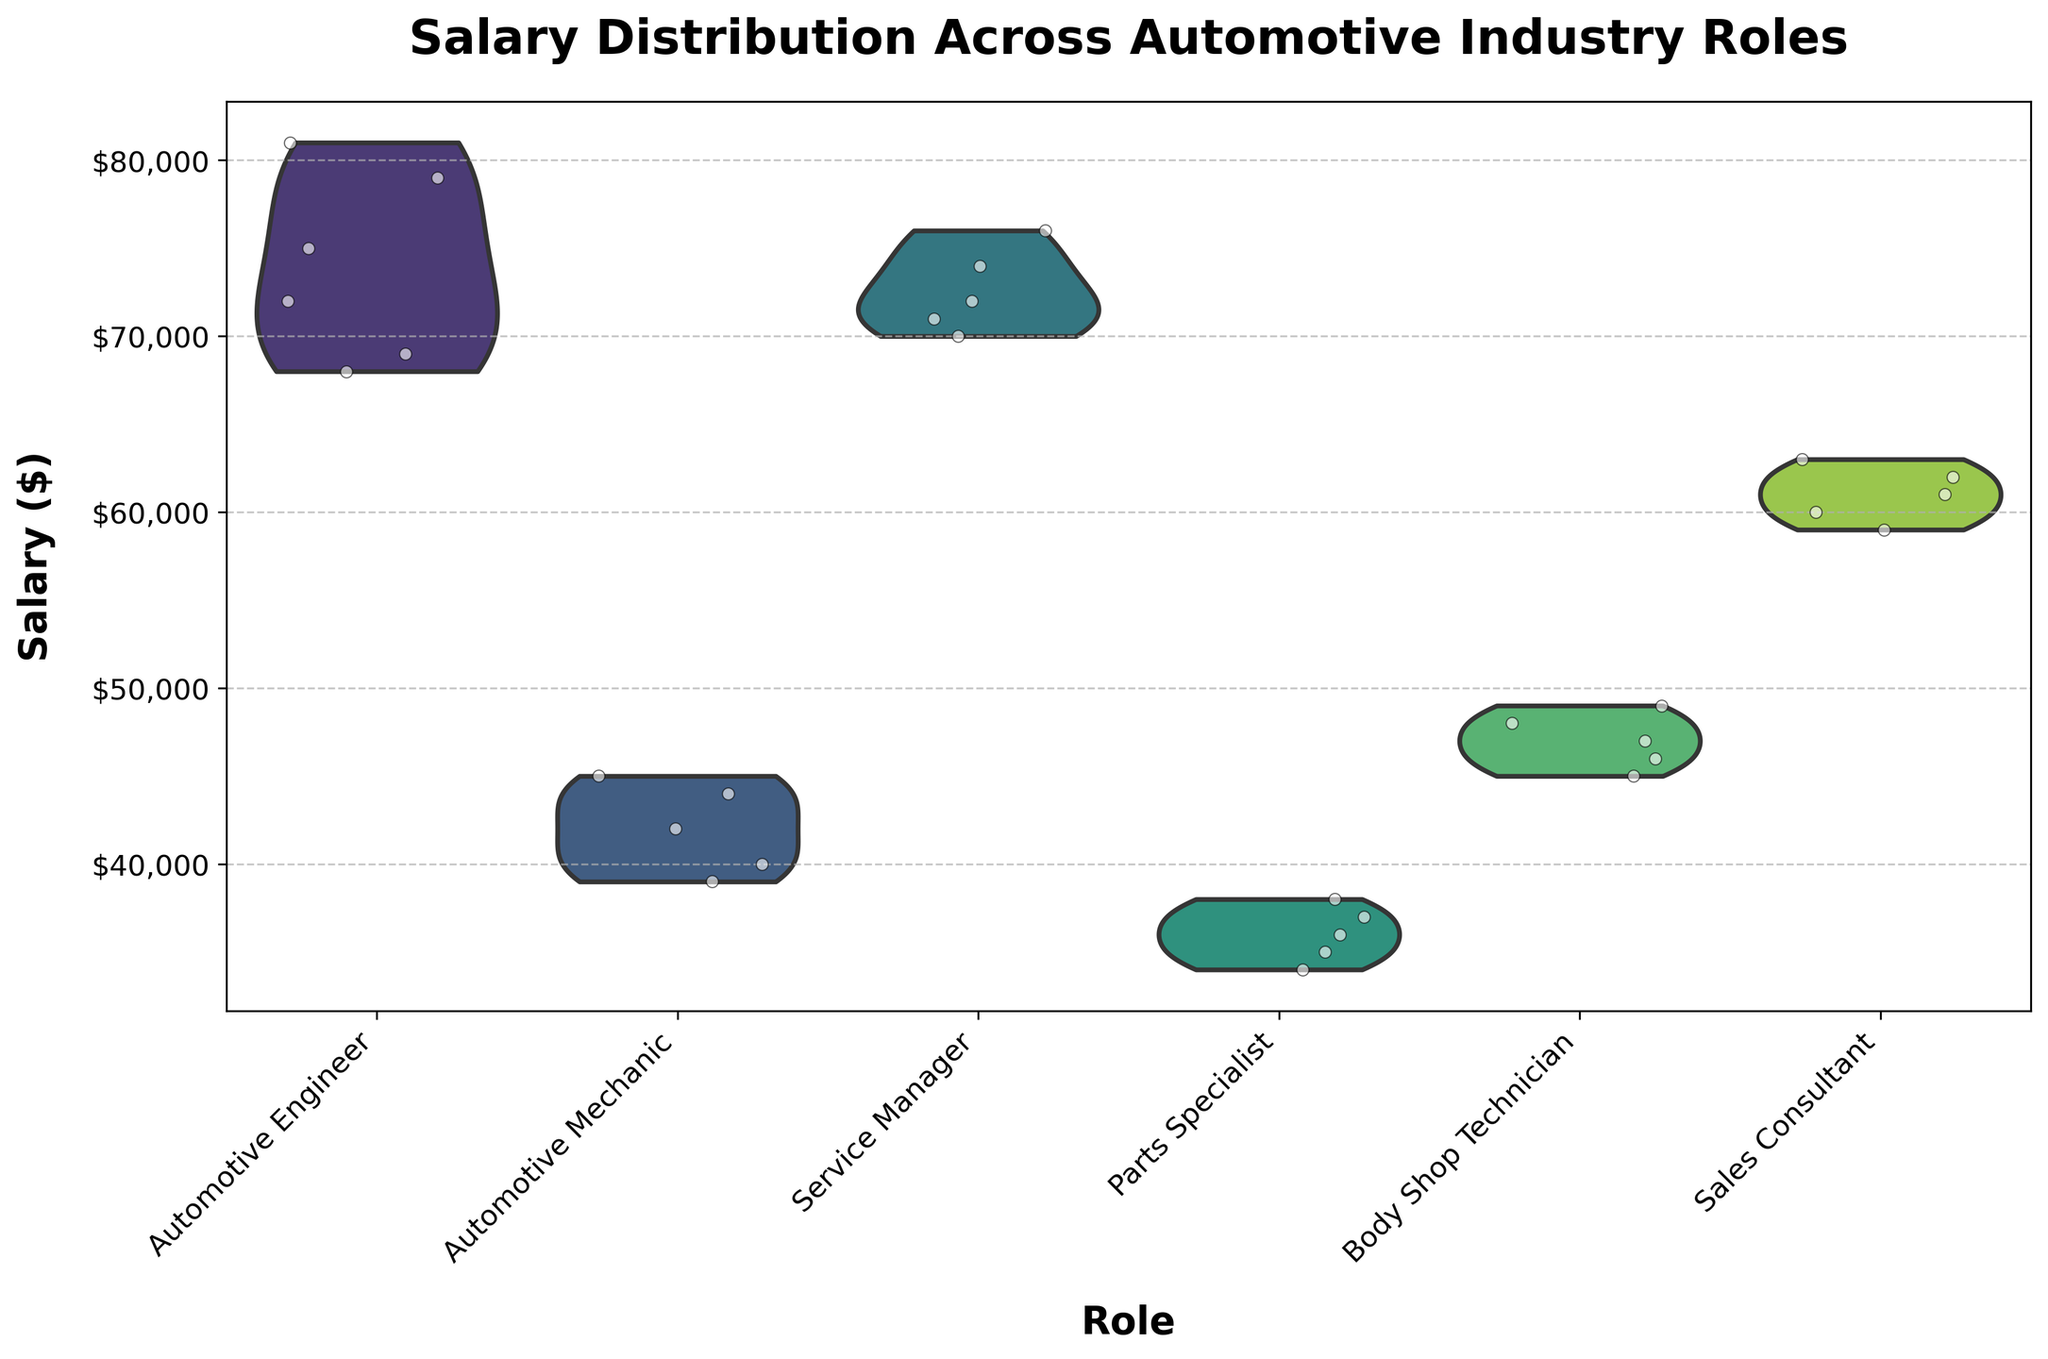What's the title of the figure? The title is typically placed at the top of the figure and describes the content. In this case, the title reads "Salary Distribution Across Automotive Industry Roles."
Answer: Salary Distribution Across Automotive Industry Roles What roles are compared in the figure? The x-axis labels in the plot denote the different roles that are being compared. They are visible as distinct categories. The roles shown are Automotive Engineer, Automotive Mechanic, Service Manager, Parts Specialist, Body Shop Technician, and Sales Consultant.
Answer: Automotive Engineer, Automotive Mechanic, Service Manager, Parts Specialist, Body Shop Technician, Sales Consultant Which role has the highest median salary? In a violin plot, the median salary is typically indicated by the thickest part of the inner distribution. By visually inspecting the plot, the role with the highest median salary is Automotive Engineer.
Answer: Automotive Engineer Which role has the lowest median salary? Similar to identifying the highest median salary, the lowest median salary can be identified by looking at the thickest part of each distribution. Parts Specialist has the lowest median salary.
Answer: Parts Specialist What is the salary range for Automotive Mechanics? The range in a violin plot is depicted by the spread of the distribution. For Automotive Mechanics, the salaries range approximately from $39,000 to $45,000.
Answer: $39,000 to $45,000 How does the salary distribution for Sales Consultants compare to Service Managers? By comparing the shapes and spread of the violin plots for Sales Consultants and Service Managers, we observe that Sales Consultants have a narrower distribution with salary figures clustered around the median, while Service Managers show a wider distribution indicating more variability.
Answer: Sales Consultants have a narrower distribution, Service Managers show more variability Which roles have the most salary overlap based on the distributions? By observing the overlap of the violin plots, it can be seen that the salary ranges of Automotive Engineer and Service Manager overlap significantly, indicating similar salary distributions.
Answer: Automotive Engineer and Service Manager What is the approximate median salary for a Body Shop Technician? The median salary in a violin plot can often be inferred from the thickest part of the distribution. For Body Shop Technicians, the median is around $47,000.
Answer: $47,000 How many data points are there for Parts Specialists? Jittered points (dots) represent individual data points in the violin plot. Counting the number of points for Parts Specialists shows there are five data points.
Answer: 5 Is there a role that has all salaries clustered in a very narrow band? A narrow band in the violin plot indicates that the salaries are very similar across that role. Automotive Mechanic has such narrow distribution, indicating tightly clustered salary figures.
Answer: Automotive Mechanic 